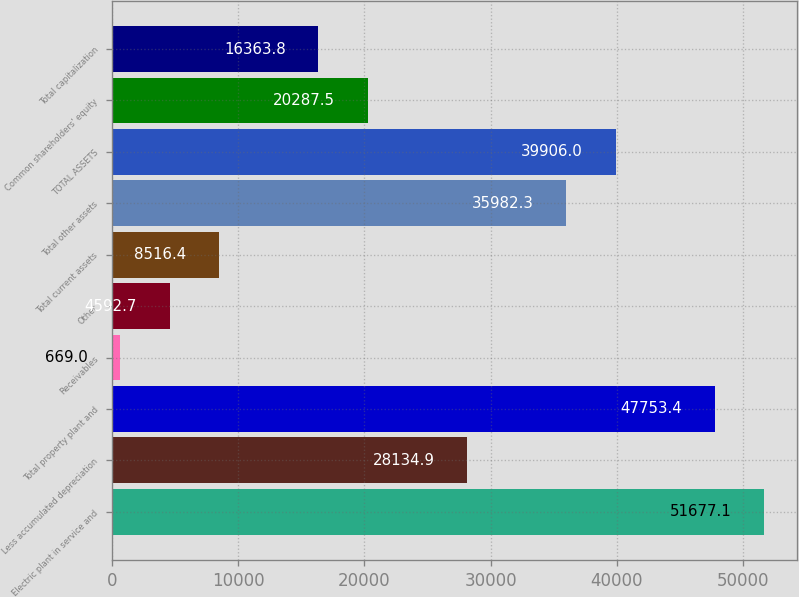<chart> <loc_0><loc_0><loc_500><loc_500><bar_chart><fcel>Electric plant in service and<fcel>Less accumulated depreciation<fcel>Total property plant and<fcel>Receivables<fcel>Other<fcel>Total current assets<fcel>Total other assets<fcel>TOTAL ASSETS<fcel>Common shareholders' equity<fcel>Total capitalization<nl><fcel>51677.1<fcel>28134.9<fcel>47753.4<fcel>669<fcel>4592.7<fcel>8516.4<fcel>35982.3<fcel>39906<fcel>20287.5<fcel>16363.8<nl></chart> 